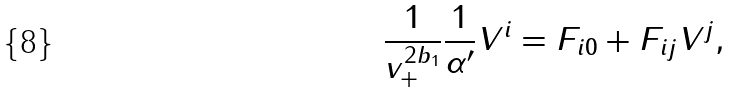<formula> <loc_0><loc_0><loc_500><loc_500>\frac { 1 } { v _ { + } ^ { 2 b _ { 1 } } } \frac { 1 } { \alpha ^ { \prime } } V ^ { i } = F _ { i 0 } + F _ { i j } V ^ { j } ,</formula> 